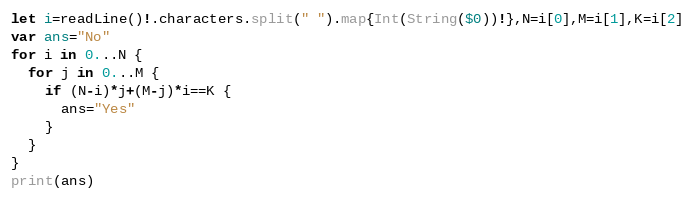Convert code to text. <code><loc_0><loc_0><loc_500><loc_500><_Swift_>let i=readLine()!.characters.split(" ").map{Int(String($0))!},N=i[0],M=i[1],K=i[2]
var ans="No"
for i in 0...N {
  for j in 0...M {
    if (N-i)*j+(M-j)*i==K {
      ans="Yes"
    }
  }
}
print(ans)</code> 